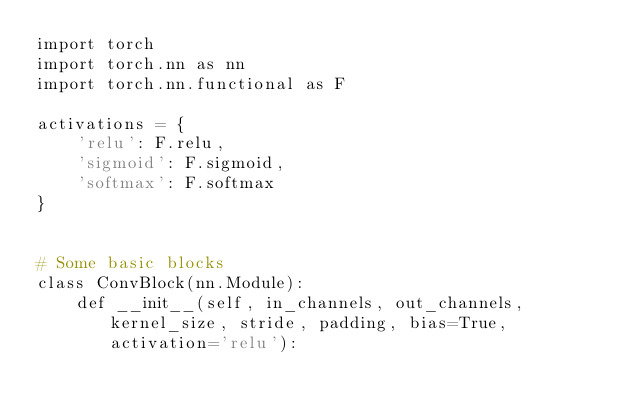Convert code to text. <code><loc_0><loc_0><loc_500><loc_500><_Python_>import torch
import torch.nn as nn
import torch.nn.functional as F

activations = {
    'relu': F.relu,
    'sigmoid': F.sigmoid,
    'softmax': F.softmax
}


# Some basic blocks
class ConvBlock(nn.Module):
    def __init__(self, in_channels, out_channels, kernel_size, stride, padding, bias=True, activation='relu'):</code> 